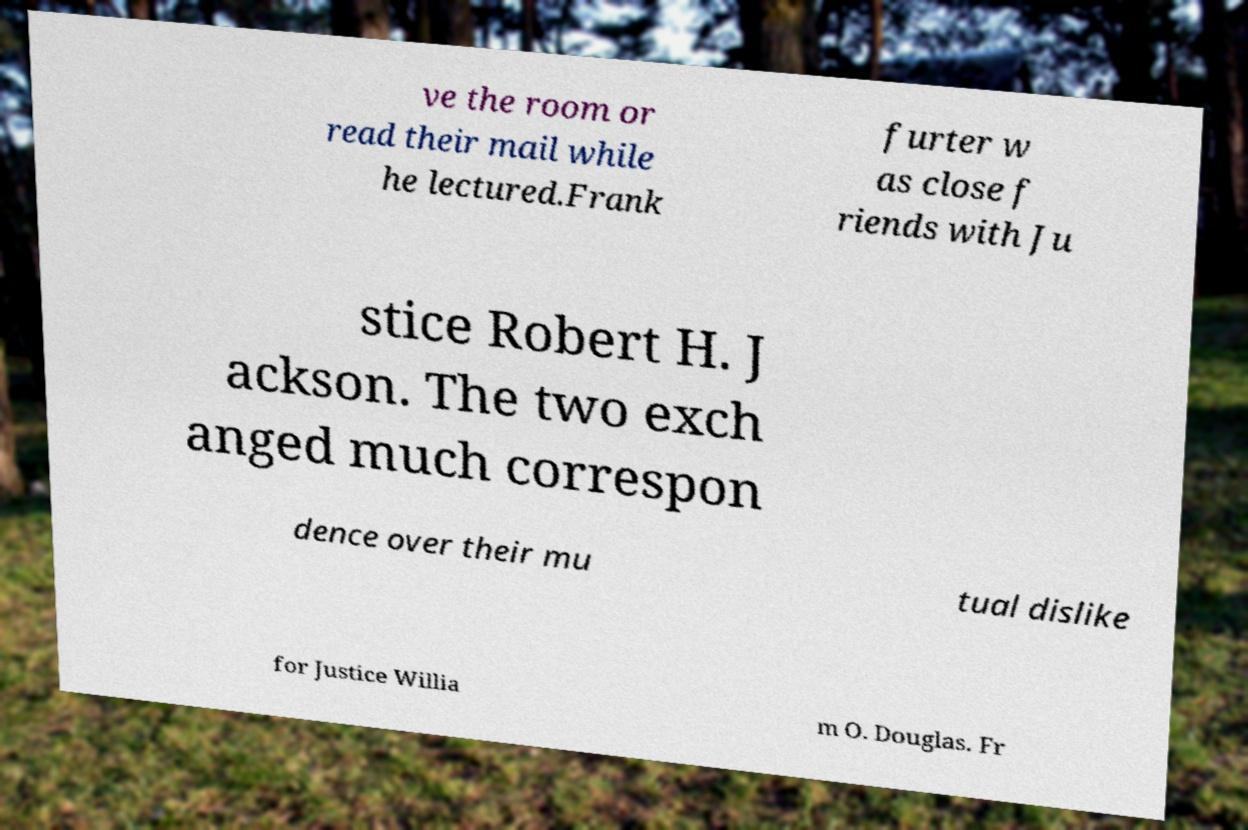Can you read and provide the text displayed in the image?This photo seems to have some interesting text. Can you extract and type it out for me? ve the room or read their mail while he lectured.Frank furter w as close f riends with Ju stice Robert H. J ackson. The two exch anged much correspon dence over their mu tual dislike for Justice Willia m O. Douglas. Fr 